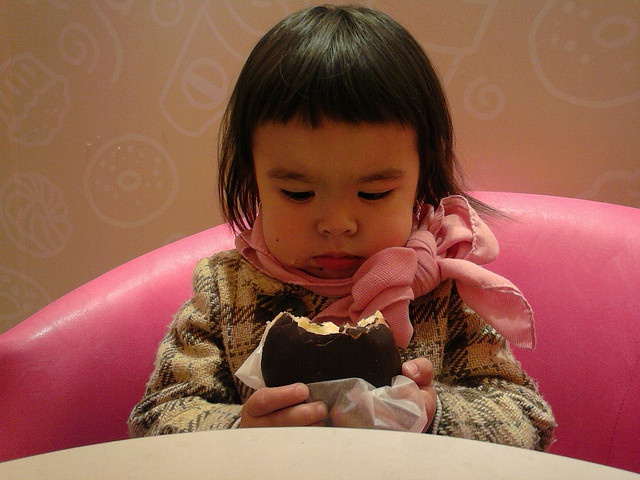Describe the objects in this image and their specific colors. I can see people in olive, black, maroon, and brown tones, chair in olive, salmon, brown, and lightpink tones, dining table in olive, tan, and brown tones, and donut in olive, black, maroon, and tan tones in this image. 